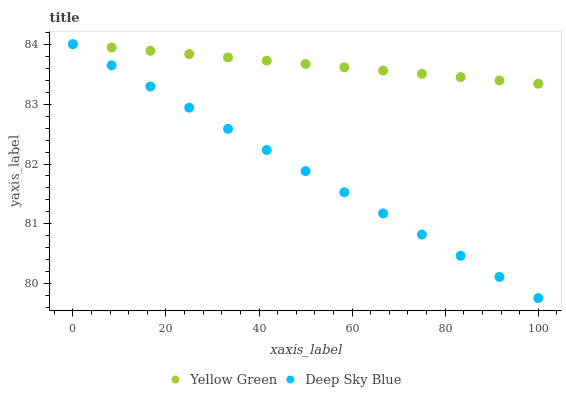Does Deep Sky Blue have the minimum area under the curve?
Answer yes or no. Yes. Does Yellow Green have the maximum area under the curve?
Answer yes or no. Yes. Does Deep Sky Blue have the maximum area under the curve?
Answer yes or no. No. Is Deep Sky Blue the smoothest?
Answer yes or no. Yes. Is Yellow Green the roughest?
Answer yes or no. Yes. Is Deep Sky Blue the roughest?
Answer yes or no. No. Does Deep Sky Blue have the lowest value?
Answer yes or no. Yes. Does Deep Sky Blue have the highest value?
Answer yes or no. Yes. Does Deep Sky Blue intersect Yellow Green?
Answer yes or no. Yes. Is Deep Sky Blue less than Yellow Green?
Answer yes or no. No. Is Deep Sky Blue greater than Yellow Green?
Answer yes or no. No. 